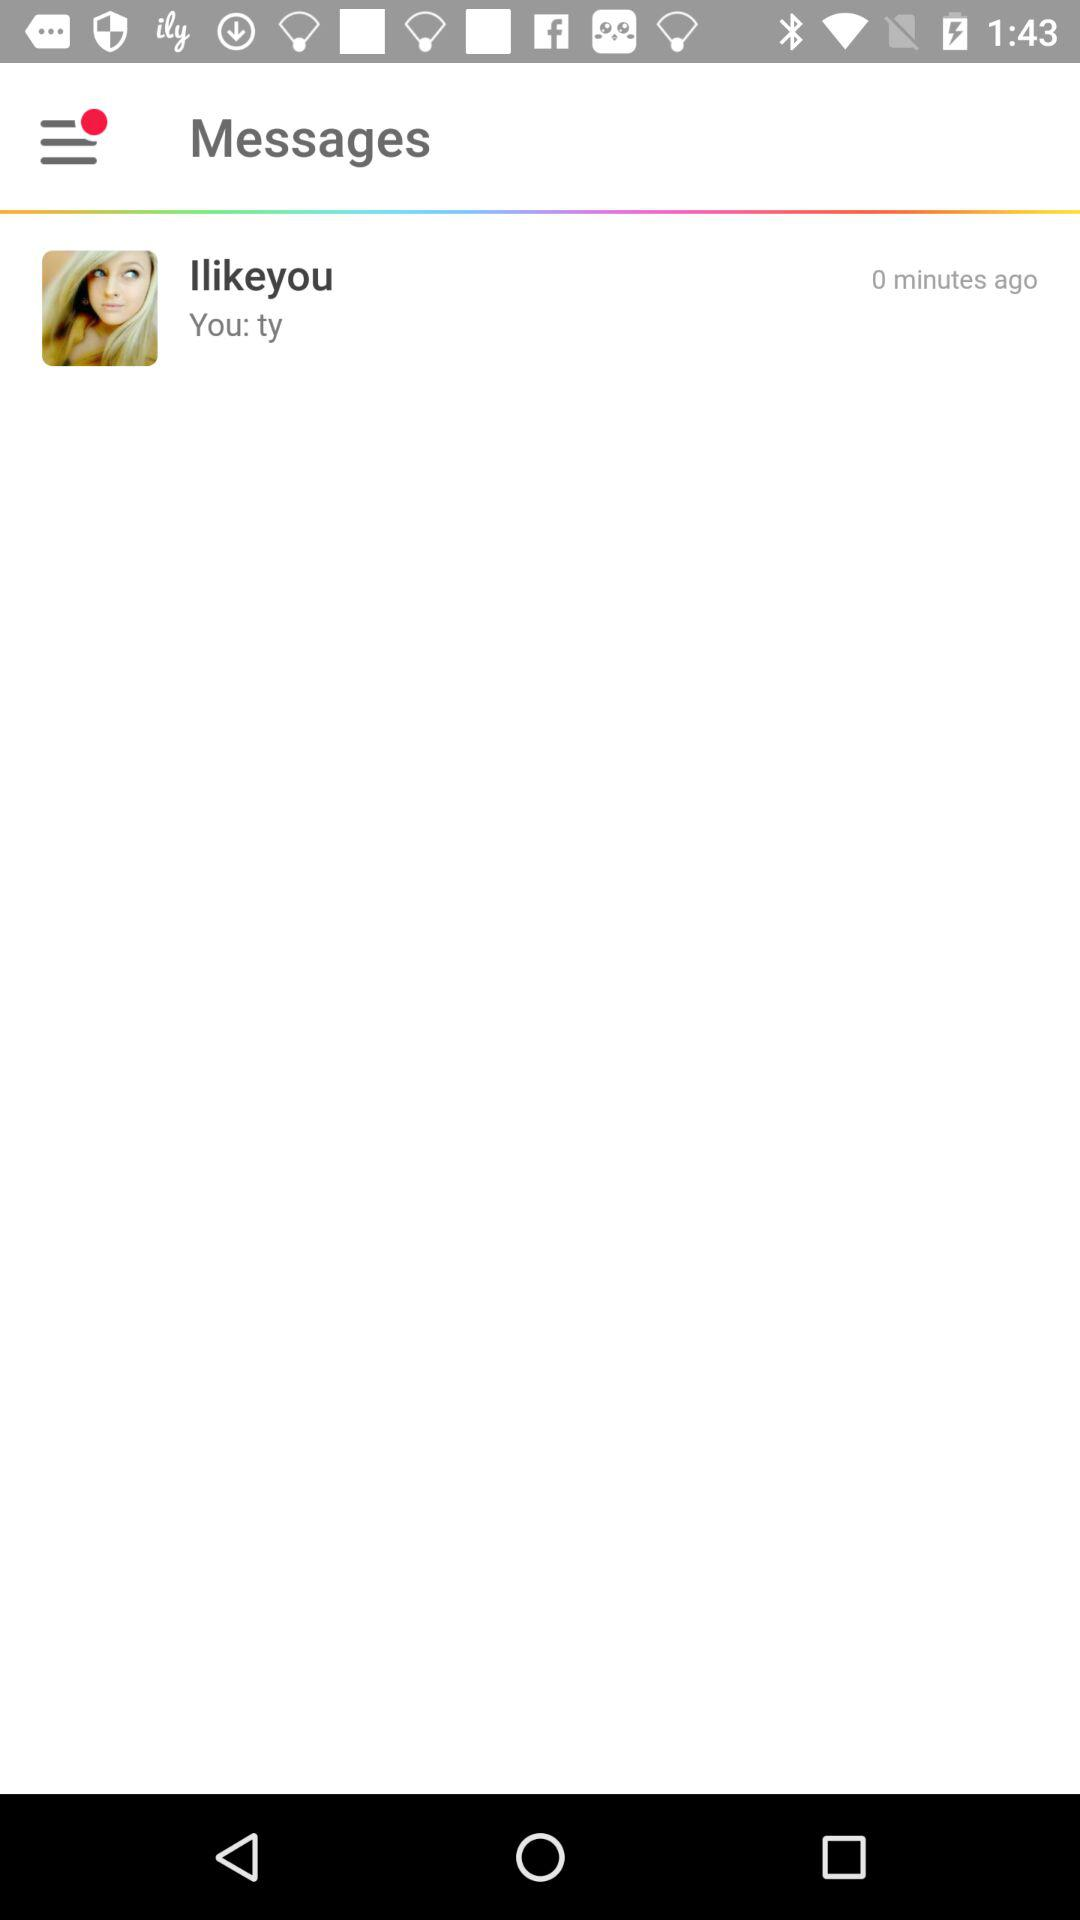When was the message received? The message was received 0 minutes ago. 